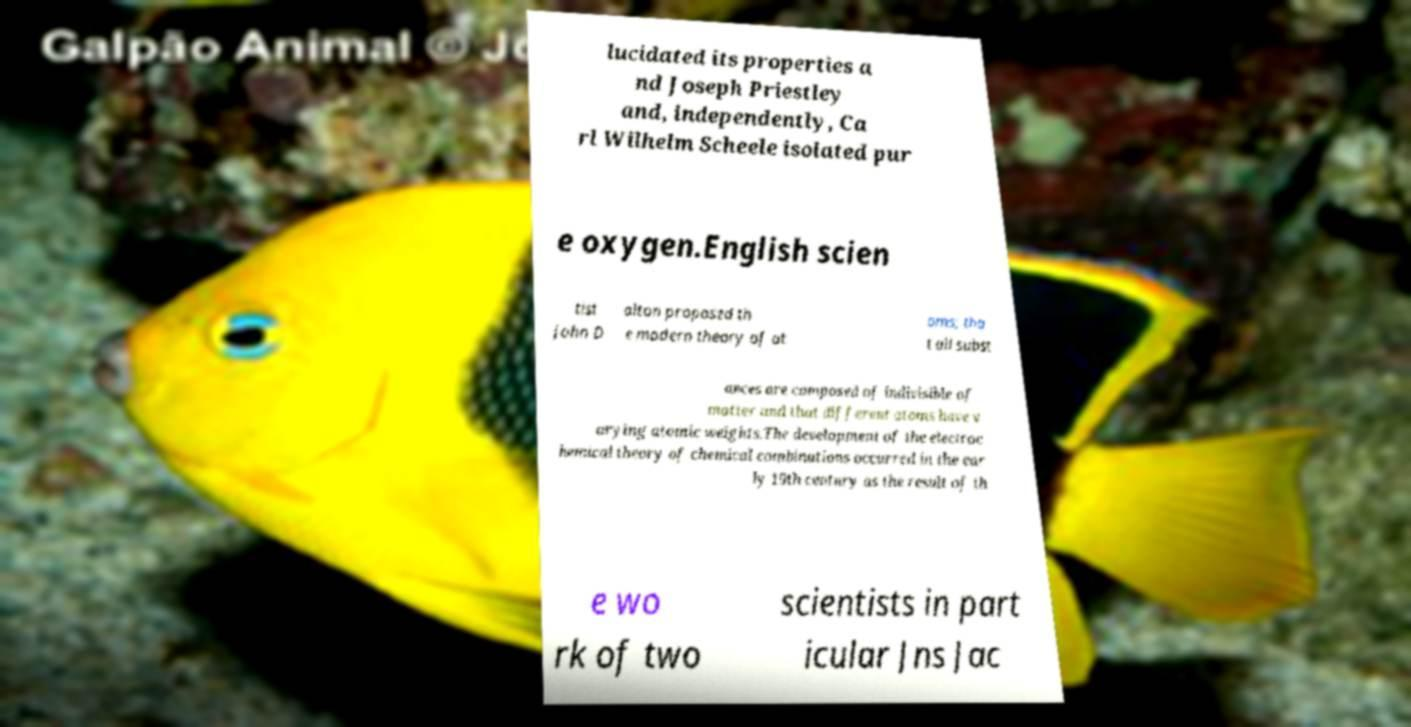For documentation purposes, I need the text within this image transcribed. Could you provide that? lucidated its properties a nd Joseph Priestley and, independently, Ca rl Wilhelm Scheele isolated pur e oxygen.English scien tist John D alton proposed th e modern theory of at oms; tha t all subst ances are composed of indivisible of matter and that different atoms have v arying atomic weights.The development of the electroc hemical theory of chemical combinations occurred in the ear ly 19th century as the result of th e wo rk of two scientists in part icular Jns Jac 